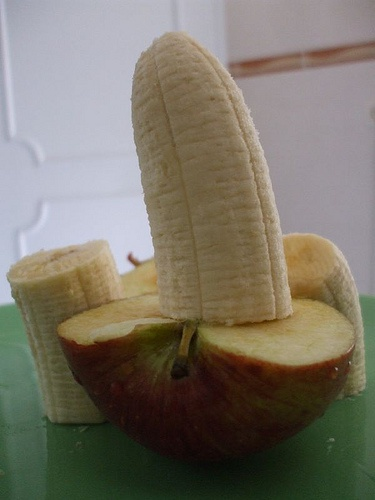Describe the objects in this image and their specific colors. I can see apple in darkgray, black, tan, maroon, and olive tones, banana in darkgray, gray, and olive tones, dining table in darkgray, black, darkgreen, and teal tones, banana in darkgray, olive, tan, and gray tones, and banana in darkgray, tan, olive, and gray tones in this image. 